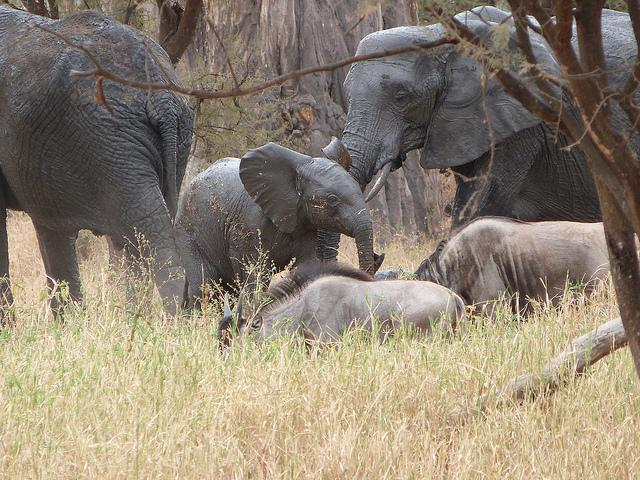What feature do these animals have? Please explain your reasoning. trunks. Elephants are grouped together in an open area. 